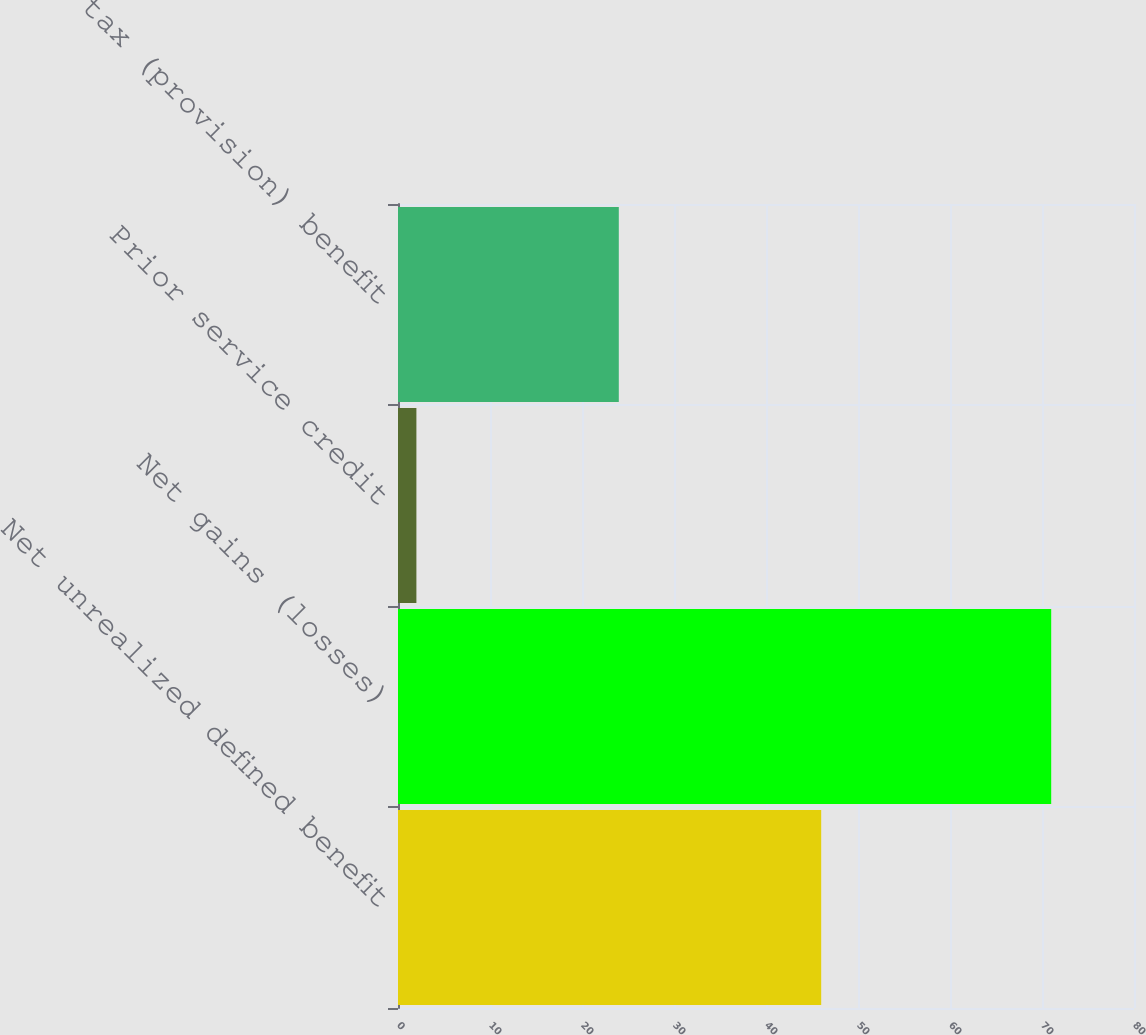Convert chart. <chart><loc_0><loc_0><loc_500><loc_500><bar_chart><fcel>Net unrealized defined benefit<fcel>Net gains (losses)<fcel>Prior service credit<fcel>Income tax (provision) benefit<nl><fcel>46<fcel>71<fcel>2<fcel>24<nl></chart> 